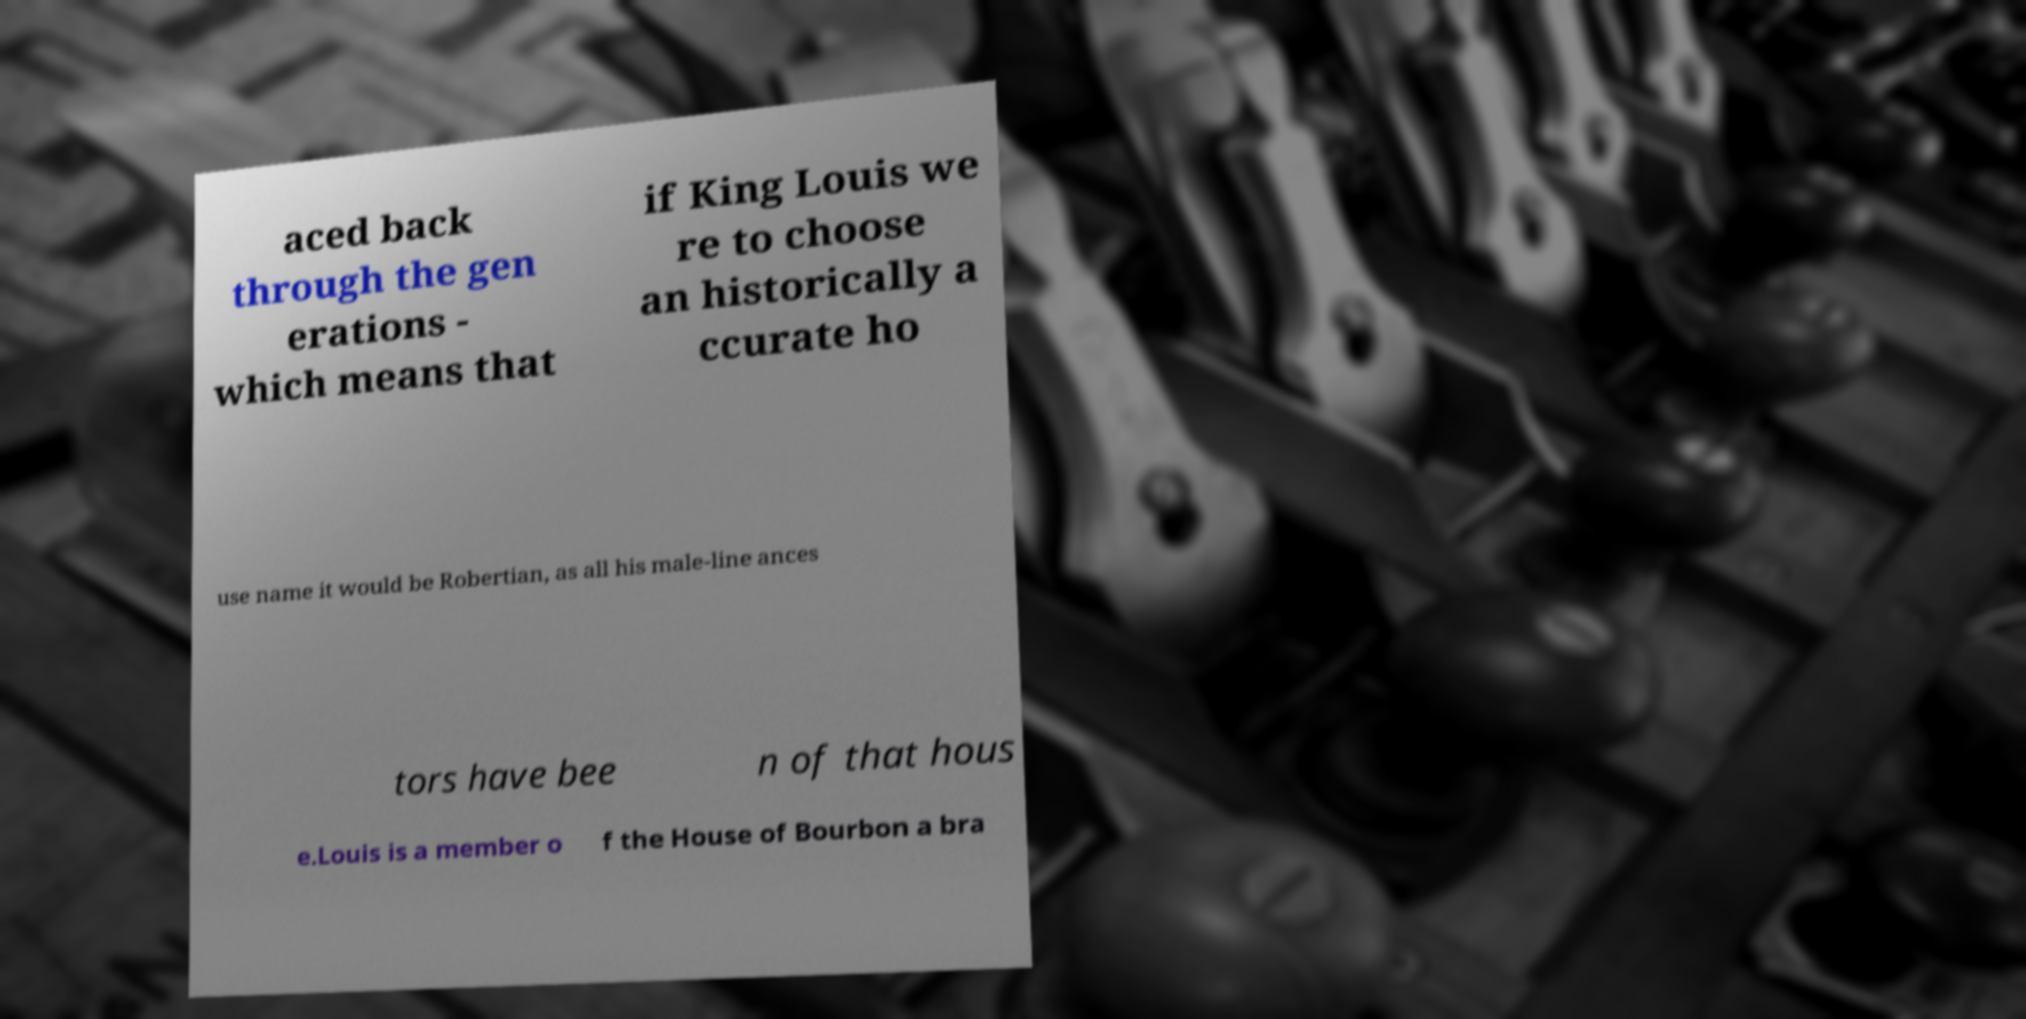Could you assist in decoding the text presented in this image and type it out clearly? aced back through the gen erations - which means that if King Louis we re to choose an historically a ccurate ho use name it would be Robertian, as all his male-line ances tors have bee n of that hous e.Louis is a member o f the House of Bourbon a bra 